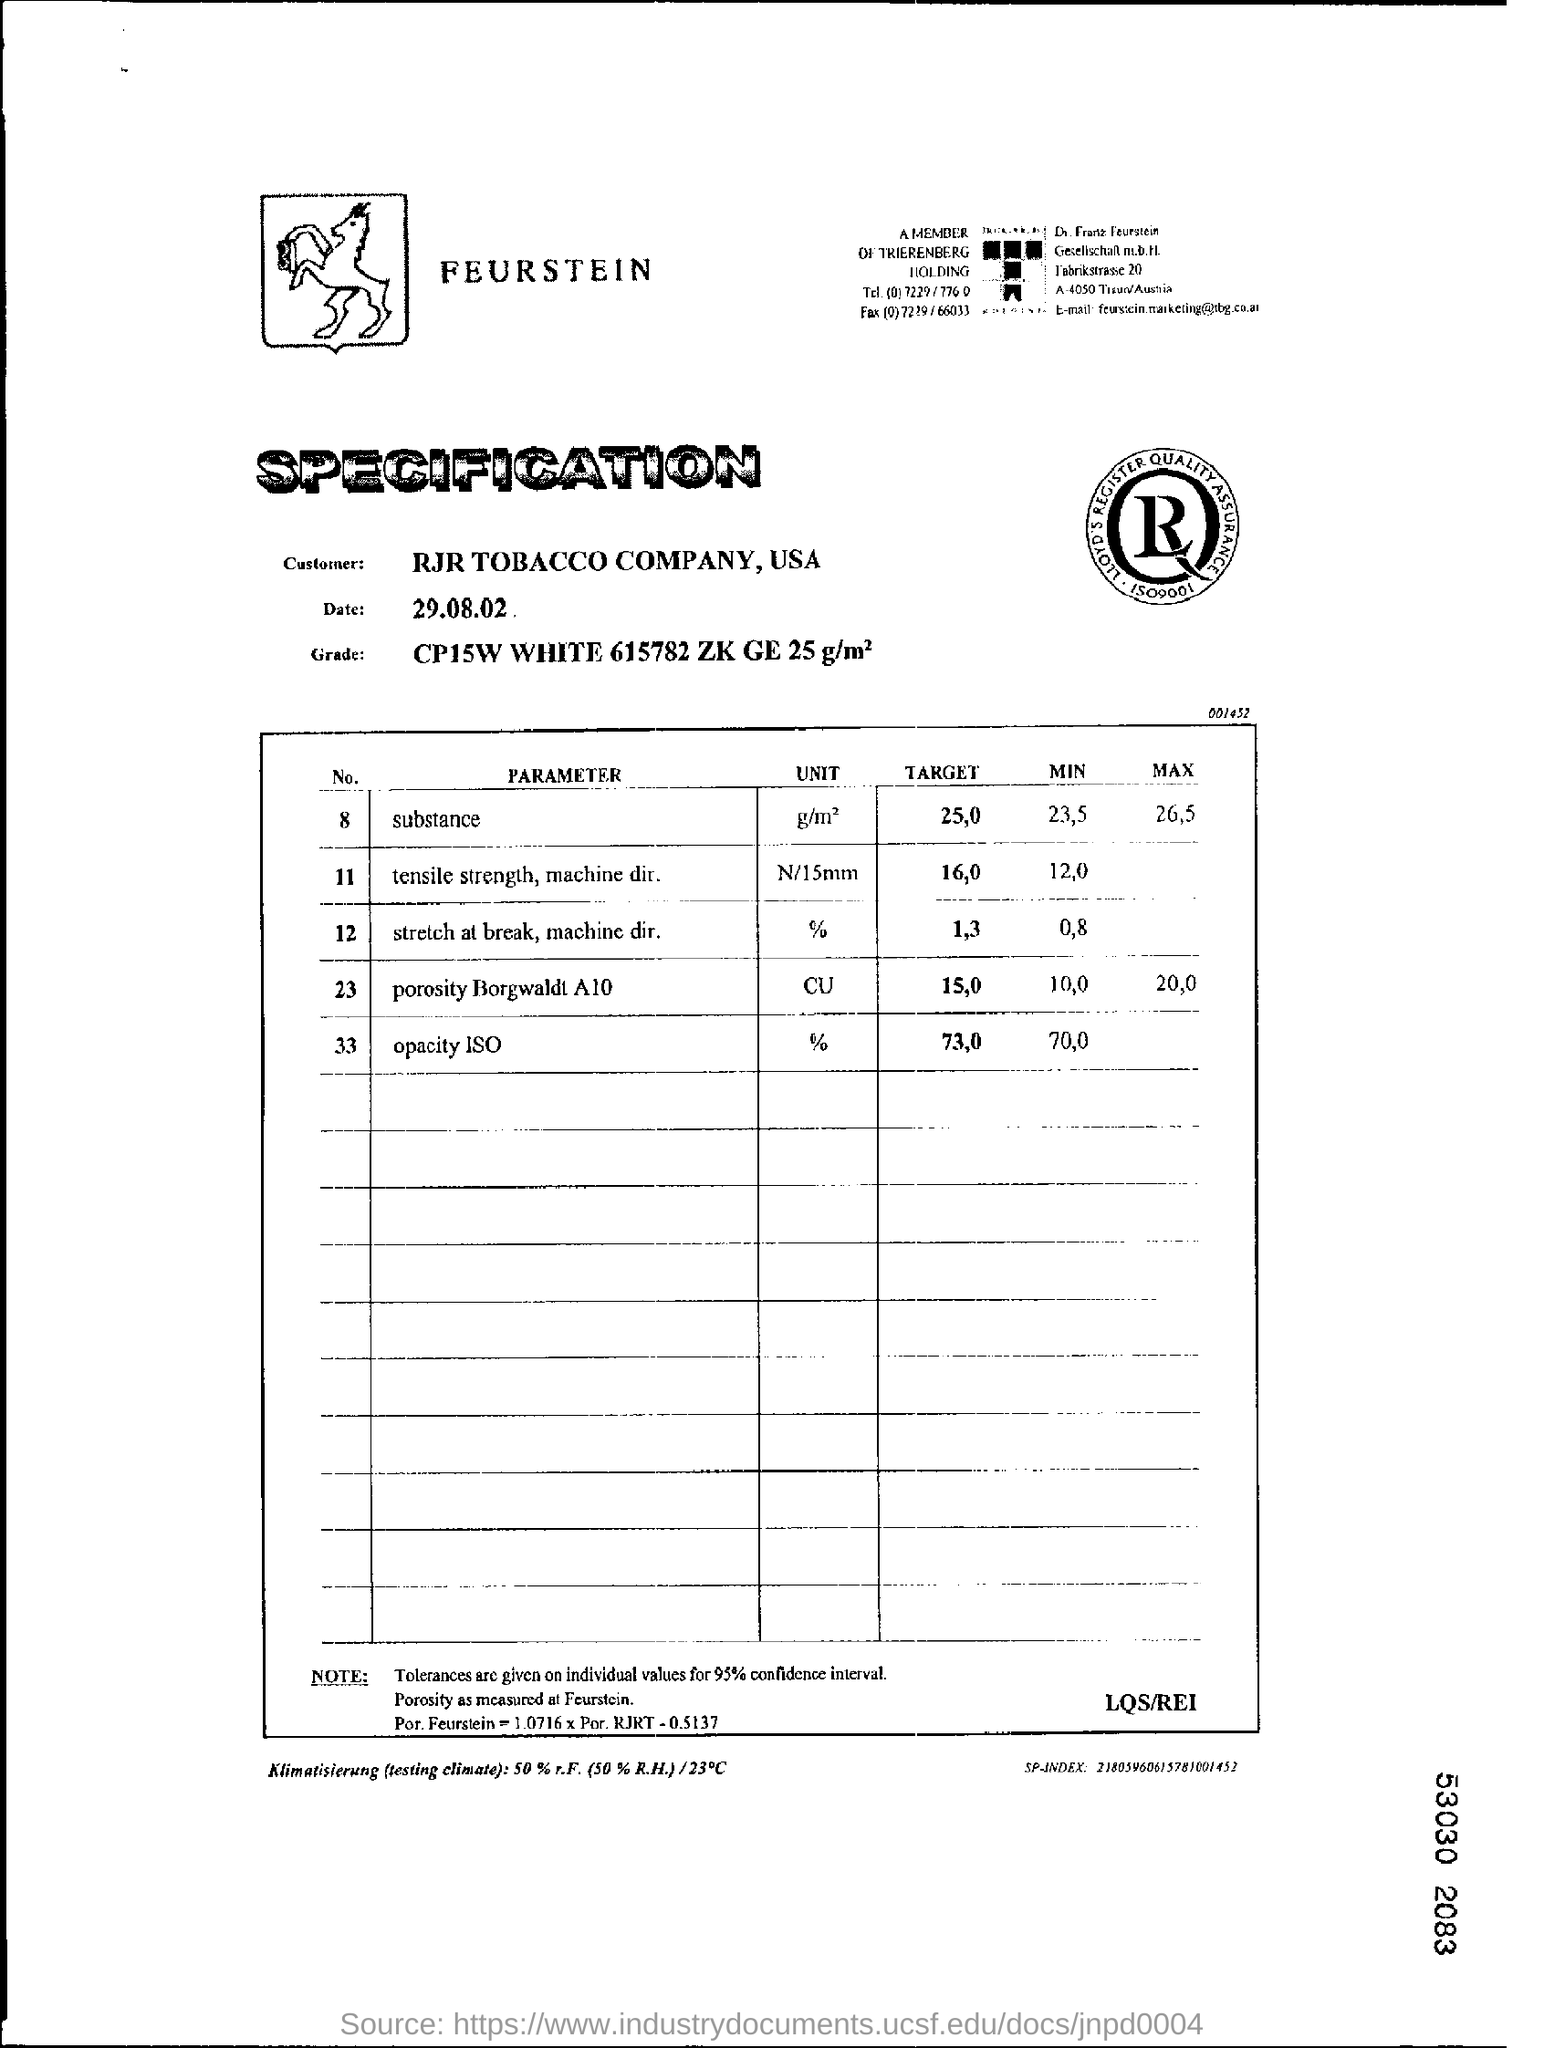Identify some key points in this picture. The parameter Porosity Borgwaldt A10 is given in units of CUBIC PERMEABILITY. The unit for opacity in the PARAMETER ISO is given as a percentage. The maximum value for the substance parameter is 26.5. The substance being referred to is the target, and the parameter is 25,0. The target value for the opacity parameter in ISO is 73,0. 